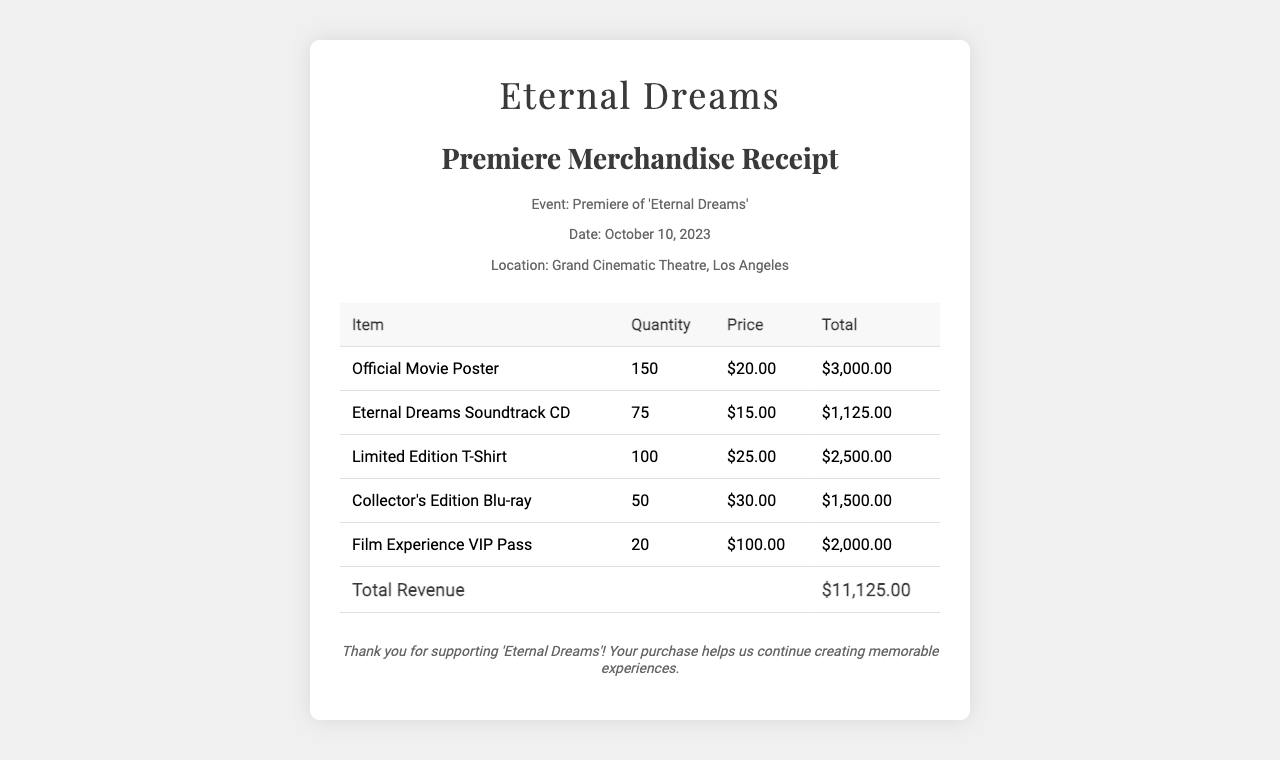What is the event name? The event name is mentioned in the document as the premiere of the film 'Eternal Dreams'.
Answer: 'Eternal Dreams' What is the date of the event? The date of the event is specified in the document as October 10, 2023.
Answer: October 10, 2023 How many official movie posters were sold? The quantity of official movie posters sold is listed as 150 in the table.
Answer: 150 What is the price of the Limited Edition T-Shirt? The price of the Limited Edition T-Shirt is provided as $25.00 in the table.
Answer: $25.00 What is the total revenue generated from merchandise sales? The total revenue is shown at the bottom of the table as the sum of all item totals, which is $11,125.00.
Answer: $11,125.00 What item had the highest quantity sold? The item with the highest quantity sold is the Official Movie Poster at 150 units.
Answer: Official Movie Poster What is the total number of Film Experience VIP Passes sold? The total number of Film Experience VIP Passes sold is indicated in the document as 20.
Answer: 20 What is the total value of the Eternal Dreams Soundtrack CDs sold? The total value of the Eternal Dreams Soundtrack CDs is calculated by multiplying the quantity (75) by the price ($15.00), resulting in $1,125.00.
Answer: $1,125.00 What is the location of the event? The location of the event is specified in the document as Grand Cinematic Theatre, Los Angeles.
Answer: Grand Cinematic Theatre, Los Angeles 